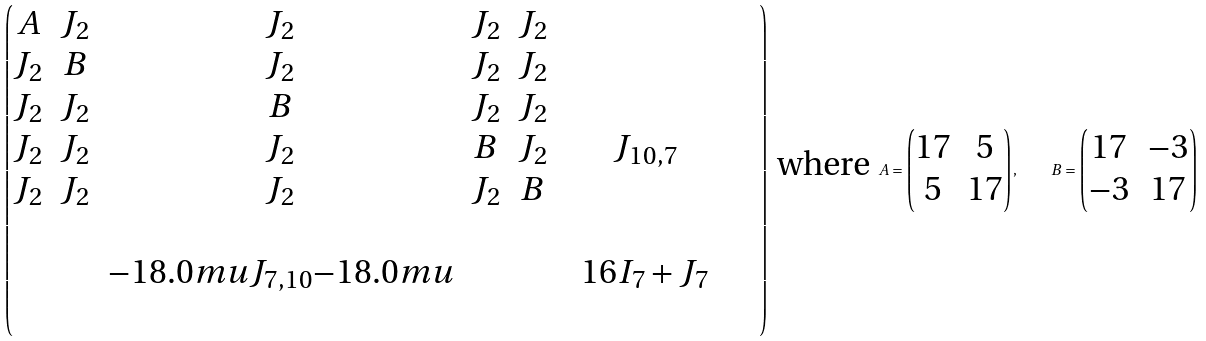<formula> <loc_0><loc_0><loc_500><loc_500>\begin{pmatrix} A & J _ { 2 } & J _ { 2 } & J _ { 2 } & J _ { 2 } & & & \\ J _ { 2 } & B & J _ { 2 } & J _ { 2 } & J _ { 2 } & & & \\ J _ { 2 } & J _ { 2 } & B & J _ { 2 } & J _ { 2 } & & & \\ J _ { 2 } & J _ { 2 } & J _ { 2 } & B & J _ { 2 } & & J _ { 1 0 , 7 } & \\ J _ { 2 } & J _ { 2 } & J _ { 2 } & J _ { 2 } & B & & & \\ & & & & & & & & & \\ & & { - 1 8 . 0 m u } J _ { 7 , 1 0 } { - 1 8 . 0 m u } & & & & 1 6 I _ { 7 } + J _ { 7 } & \\ & & & & & & & & & \\ \end{pmatrix} \text { where } A = \begin{pmatrix} 1 7 & 5 \\ 5 & 1 7 \end{pmatrix} , \quad B = \begin{pmatrix} 1 7 & - 3 \\ - 3 & 1 7 \end{pmatrix}</formula> 